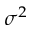<formula> <loc_0><loc_0><loc_500><loc_500>\sigma ^ { 2 }</formula> 